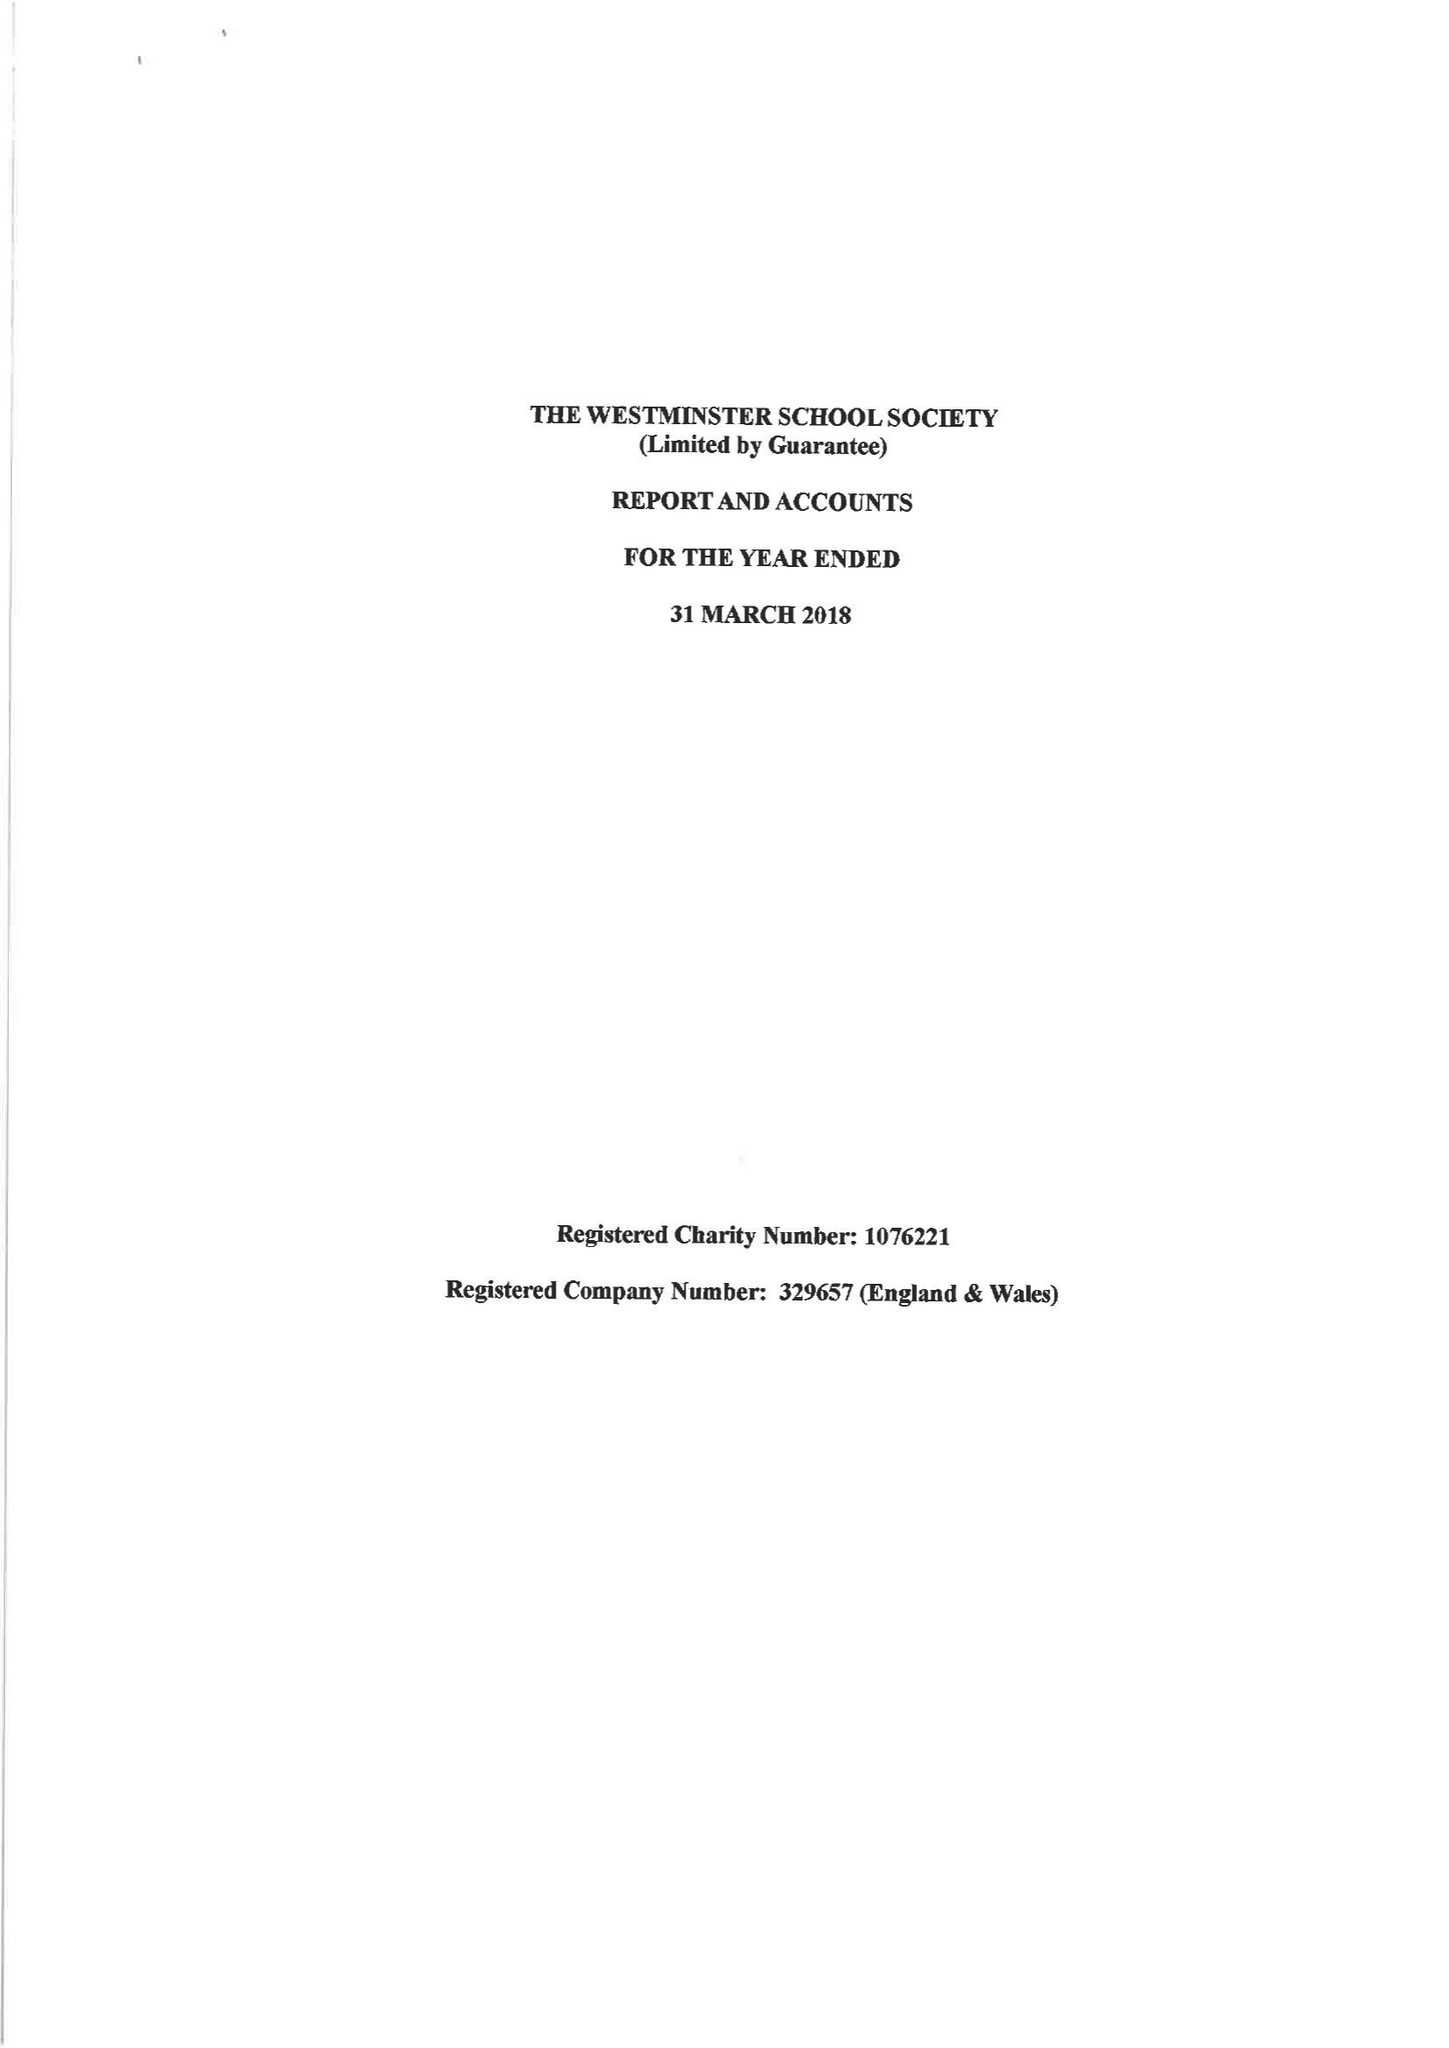What is the value for the income_annually_in_british_pounds?
Answer the question using a single word or phrase. 322926.00 